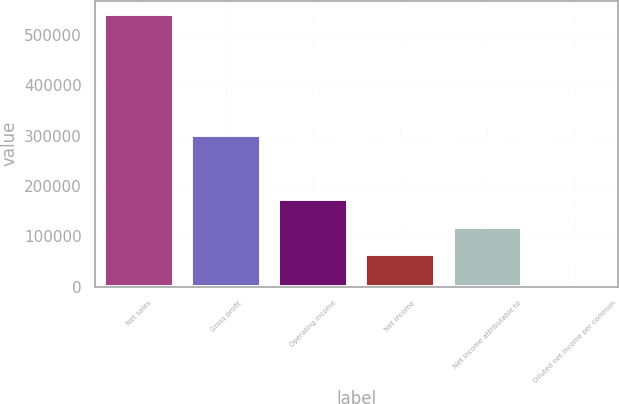<chart> <loc_0><loc_0><loc_500><loc_500><bar_chart><fcel>Net sales<fcel>Gross profit<fcel>Operating income<fcel>Net income<fcel>Net income attributable to<fcel>Diluted net income per common<nl><fcel>541391<fcel>300950<fcel>173177<fcel>64899<fcel>119038<fcel>0.3<nl></chart> 